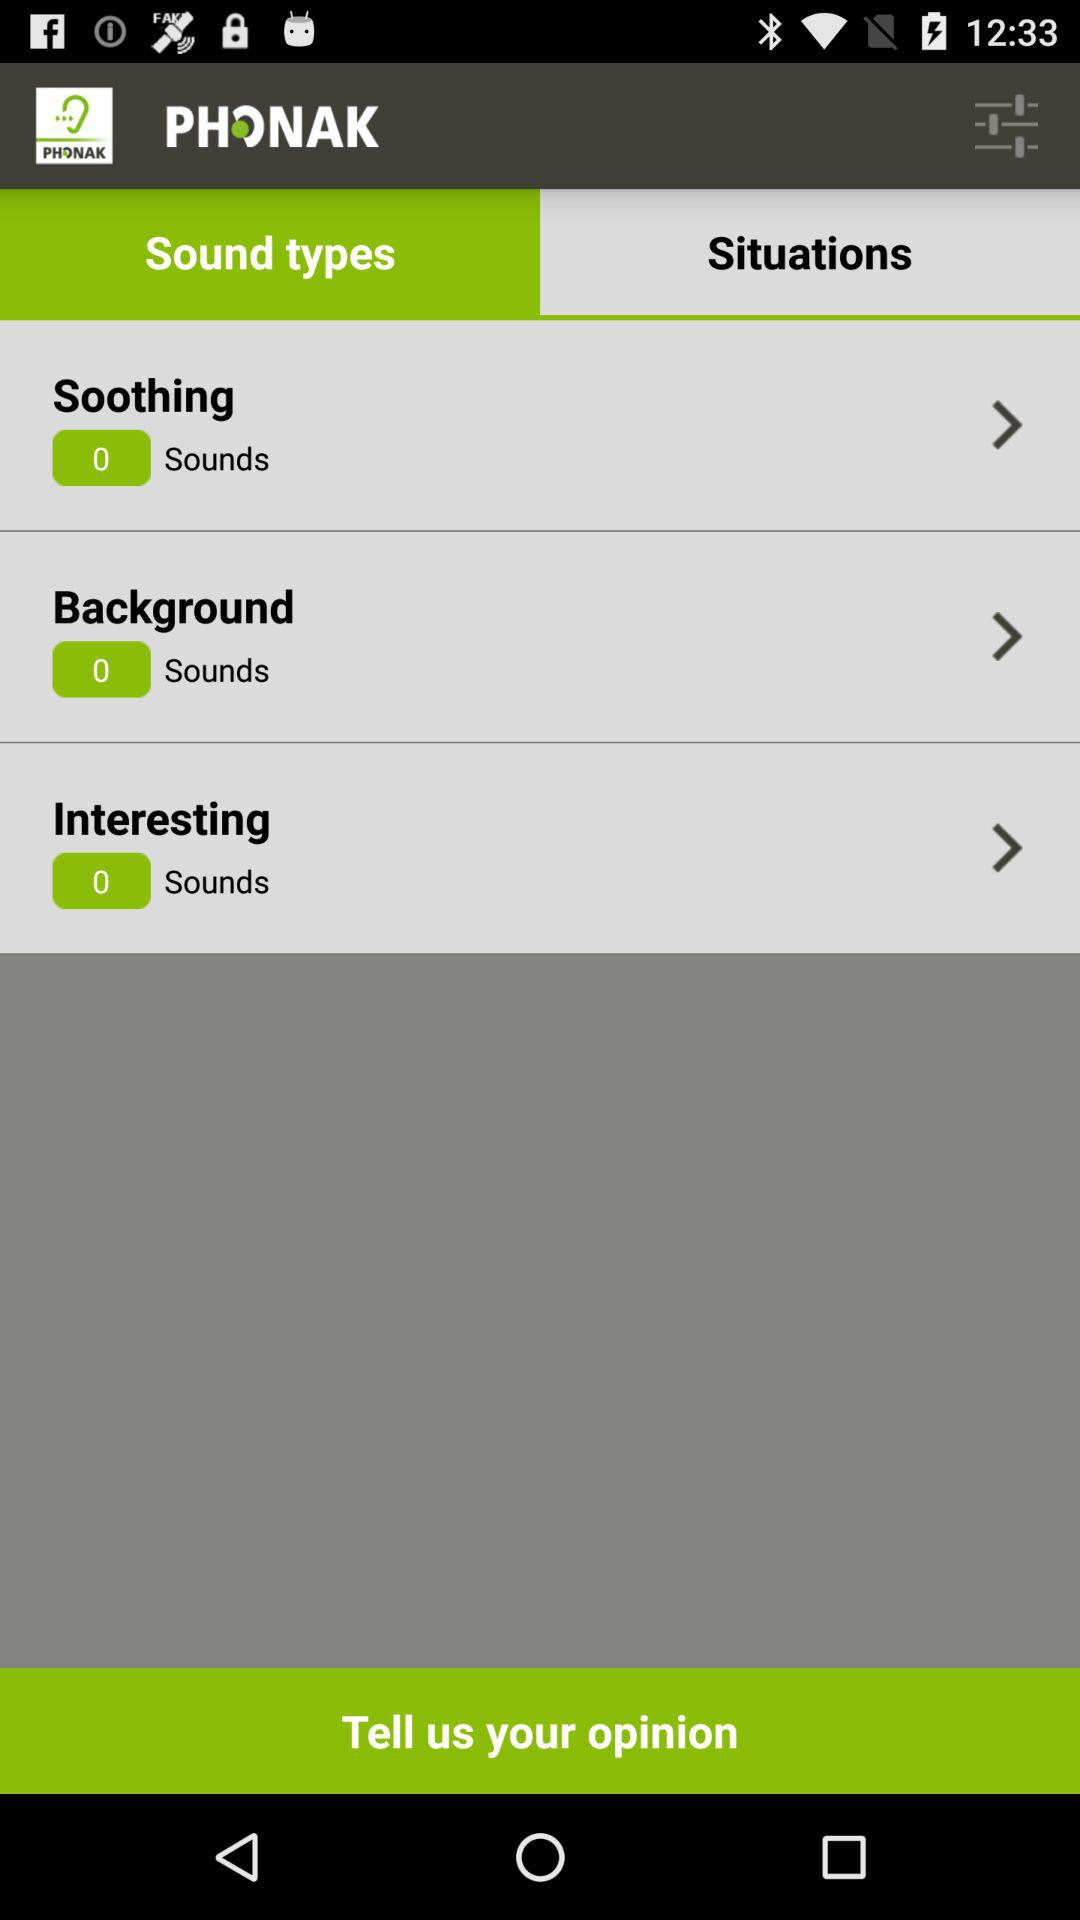What is the application name? The application name is "Tinnitus Balance". 